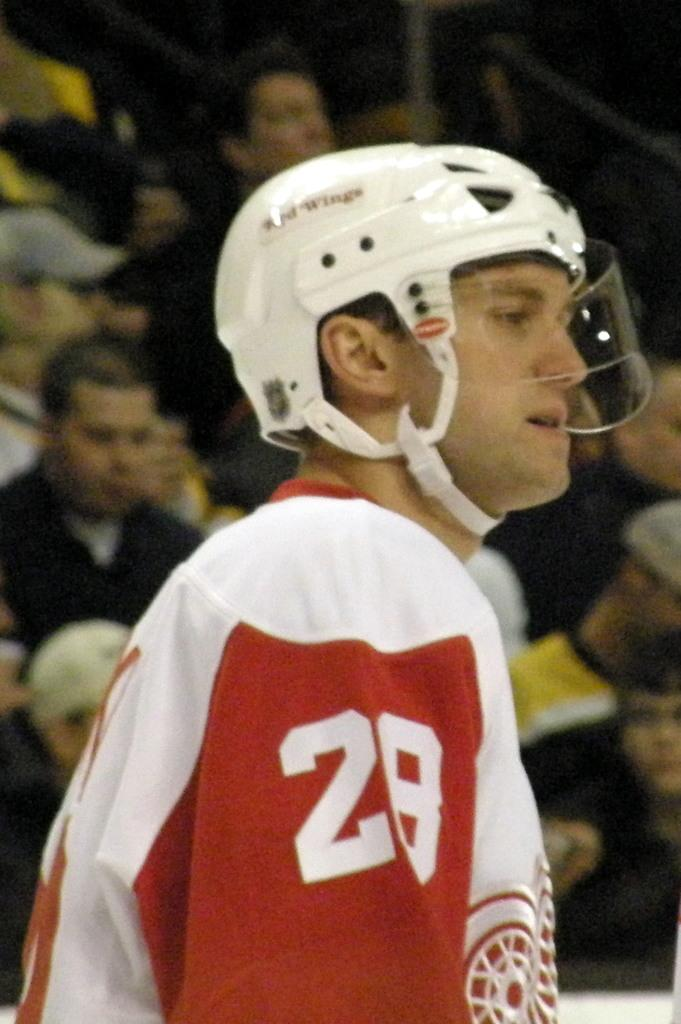What is the main subject in the foreground of the image? There is a person wearing a helmet in the foreground of the image. Can you describe the group of people in the background of the image? There is a group of people in the background of the image. What type of square object can be seen in the aftermath of the event in the image? There is no square object or event present in the image. How is the glue being used by the person wearing a helmet in the image? There is no glue present in the image, and the person wearing a helmet is not shown using any glue. 